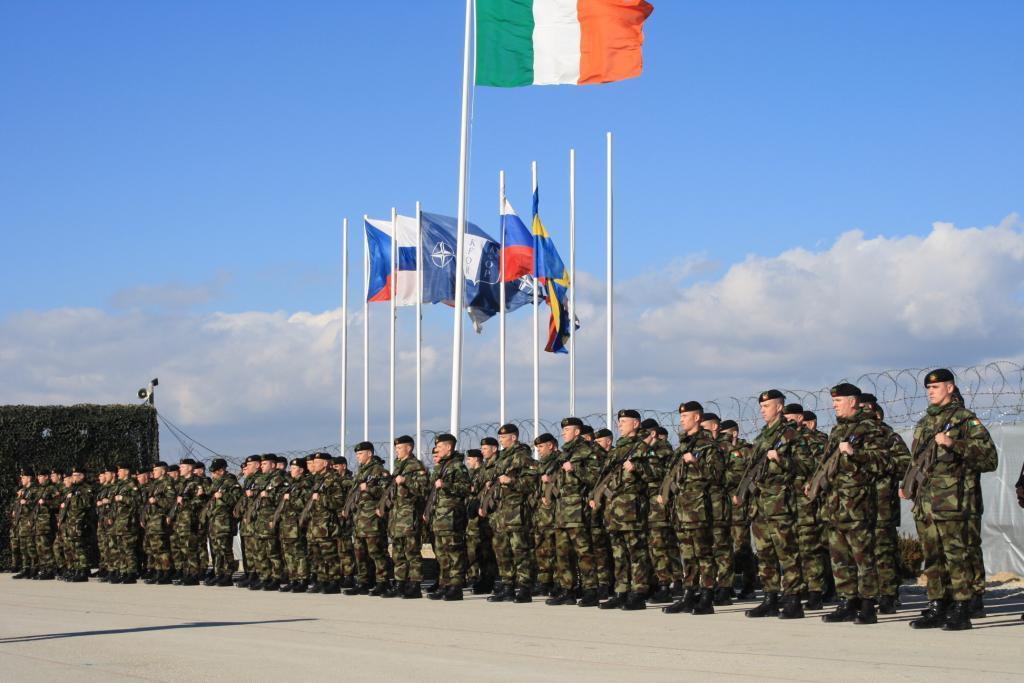Could you give a brief overview of what you see in this image? In this image, we can see people wearing uniforms and caps and are holding guns. In the background, there are flags and poles and we can see a fence. At the top, there are clouds in the sky and at the bottom, there is a road. 